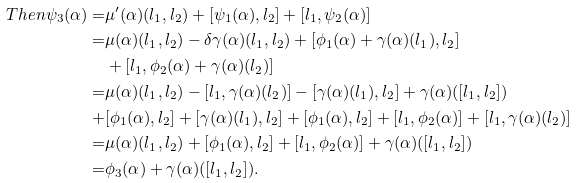Convert formula to latex. <formula><loc_0><loc_0><loc_500><loc_500>T h e n \psi _ { 3 } ( \alpha ) = & \mu ^ { \prime } ( \alpha ) ( l _ { 1 } , l _ { 2 } ) + [ \psi _ { 1 } ( \alpha ) , l _ { 2 } ] + [ l _ { 1 } , \psi _ { 2 } ( \alpha ) ] \\ = & \mu ( \alpha ) ( l _ { 1 } , l _ { 2 } ) - \delta \gamma ( \alpha ) ( l _ { 1 } , l _ { 2 } ) + [ \phi _ { 1 } ( \alpha ) + \gamma ( \alpha ) ( l _ { 1 } ) , l _ { 2 } ] \\ & + [ l _ { 1 } , \phi _ { 2 } ( \alpha ) + \gamma ( \alpha ) ( l _ { 2 } ) ] \\ = & \mu ( \alpha ) ( l _ { 1 } , l _ { 2 } ) - [ l _ { 1 } , \gamma ( \alpha ) ( l _ { 2 } ) ] - [ \gamma ( \alpha ) ( l _ { 1 } ) , l _ { 2 } ] + \gamma ( \alpha ) ( [ l _ { 1 } , l _ { 2 } ] ) \\ + & [ \phi _ { 1 } ( \alpha ) , l _ { 2 } ] + [ \gamma ( \alpha ) ( l _ { 1 } ) , l _ { 2 } ] + [ \phi _ { 1 } ( \alpha ) , l _ { 2 } ] + [ l _ { 1 } , \phi _ { 2 } ( \alpha ) ] + [ l _ { 1 } , \gamma ( \alpha ) ( l _ { 2 } ) ] \\ = & \mu ( \alpha ) ( l _ { 1 } , l _ { 2 } ) + [ \phi _ { 1 } ( \alpha ) , l _ { 2 } ] + [ l _ { 1 } , \phi _ { 2 } ( \alpha ) ] + \gamma ( \alpha ) ( [ l _ { 1 } , l _ { 2 } ] ) \\ = & \phi _ { 3 } ( \alpha ) + \gamma ( \alpha ) ( [ l _ { 1 } , l _ { 2 } ] ) .</formula> 